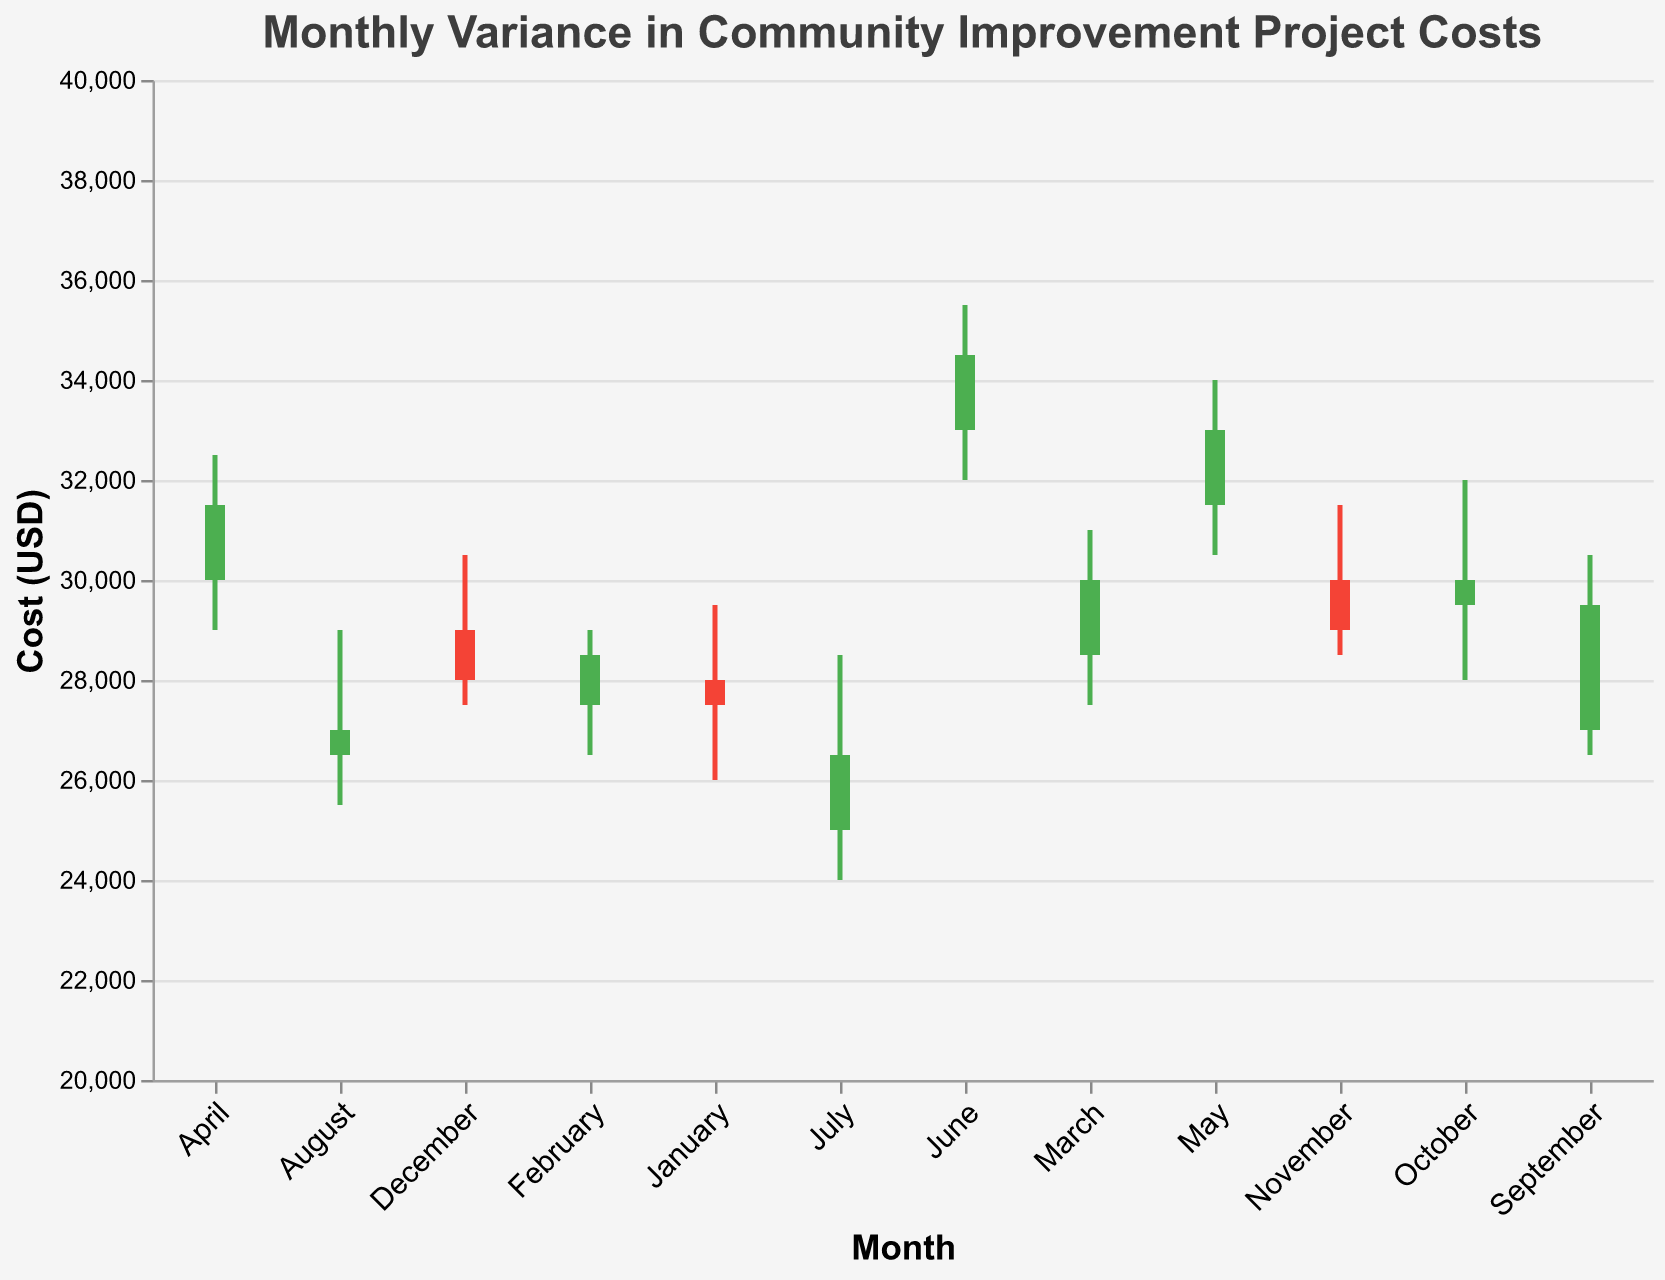How many months show an increase in the closing cost compared to the opening cost? To determine this, look for bars colored in green because the encoding specifies green bars for months where the closing cost is higher than the opening cost. By examining the chart, count the number of green bars.
Answer: 7 Which month had the highest project costs? Look for the month where the high value reaches the maximum point on the y-axis. This is represented by the upper end of the vertical line extending from the bar. The highest project cost occurs in June with a high of 35500.
Answer: June What is the range of project costs in November? The range of project costs in November can be determined by calculating the difference between the highest value and the lowest value for that month. The high is 31500, and the low is 28500. Therefore, the range is 31500 - 28500 = 3000.
Answer: 3000 Which month had the most significant variance in project costs (difference between high and low)? To find this, look for the month where the line extending from the bar covers the largest vertical distance. Comparing all months, June shows the most significant variance, ranging from 32000 to 35500. Therefore, the variance is 35500 - 32000 = 3500.
Answer: June How did project costs trend over the year? Observe the movement of both the open and close prices throughout the months. The costs generally increase over the year, starting from 25000 in July and rising to a closing cost of 34500 in June. Although there are some fluctuations, there is a clear upward trend.
Answer: Upward trend Which month saw the largest monthly increase from opening to closing costs? The largest monthly increase can be found by calculating the difference between the closing and opening costs for each month and identifying the largest positive difference. For September, the opening cost was 27000, and the closing cost was 29500, making an increase of 29500 - 27000 = 2500, the largest of all months.
Answer: September What are the opening and closing costs for December? Examine the chart where the bar represents December. The bottom and top of the bar correspond to the opening and closing costs respectively. The opening cost for December is 29000, and the closing cost is 28000.
Answer: 29000, 28000 Which month had the lowest closing cost, and what was it? Look for the lowest point on the y-axis where the end of a bar (representing the closing cost) is located. December has the lowest closing cost at 28000.
Answer: December What is the average closing cost over the fiscal year? Sum all the closing costs for each month and divide by the number of months (12). The closing costs are: 26500, 27000, 29500, 30000, 29000, 28000, 27500, 28500, 30000, 31500, 33000, 34500. The sum is 375500, so the average is 375500 / 12 = 31291.67.
Answer: 31291.67 How does the variability of project costs from month to month appear in the chart? Look at the length of the vertical lines extending from the bars which represent the range between the high and low values for each month. Months with longer lines show more variability. Notably, June and September show significant variability while months like November and February show less variability.
Answer: Mixed variability 